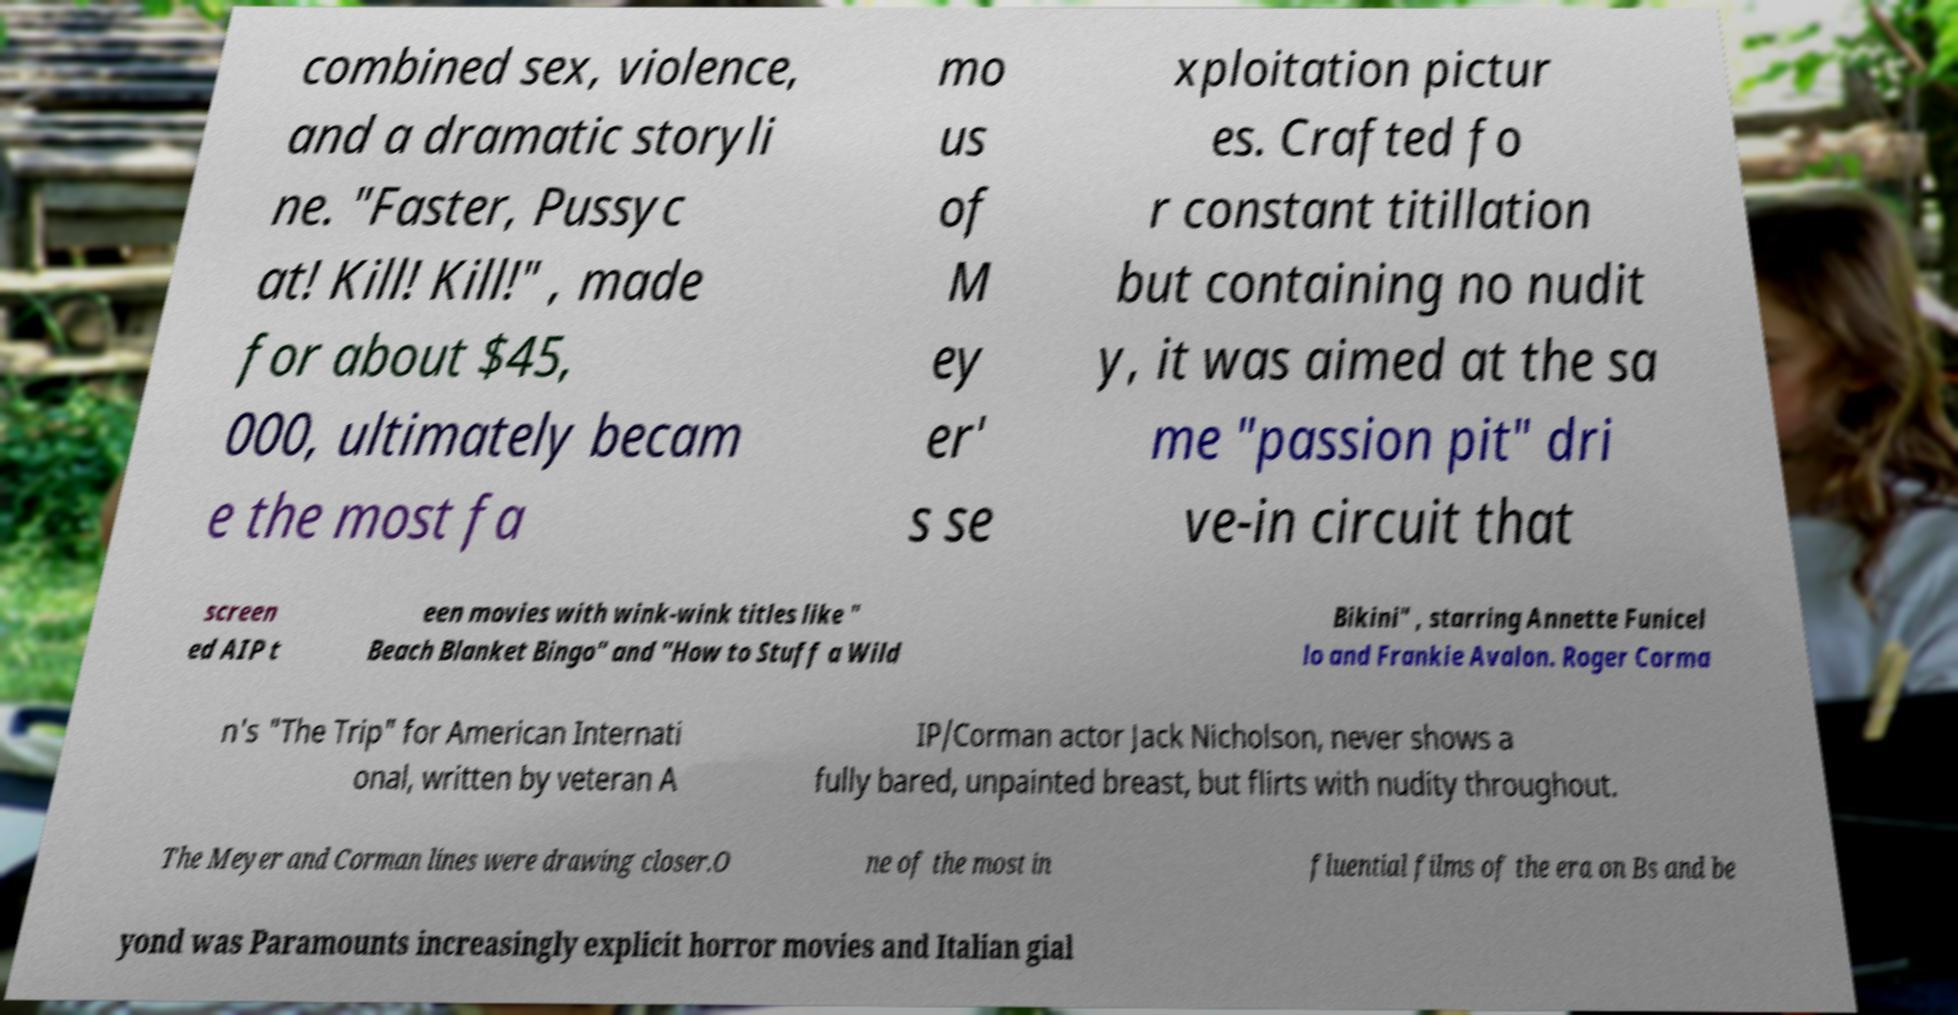Can you read and provide the text displayed in the image?This photo seems to have some interesting text. Can you extract and type it out for me? combined sex, violence, and a dramatic storyli ne. "Faster, Pussyc at! Kill! Kill!" , made for about $45, 000, ultimately becam e the most fa mo us of M ey er' s se xploitation pictur es. Crafted fo r constant titillation but containing no nudit y, it was aimed at the sa me "passion pit" dri ve-in circuit that screen ed AIP t een movies with wink-wink titles like " Beach Blanket Bingo" and "How to Stuff a Wild Bikini" , starring Annette Funicel lo and Frankie Avalon. Roger Corma n's "The Trip" for American Internati onal, written by veteran A IP/Corman actor Jack Nicholson, never shows a fully bared, unpainted breast, but flirts with nudity throughout. The Meyer and Corman lines were drawing closer.O ne of the most in fluential films of the era on Bs and be yond was Paramounts increasingly explicit horror movies and Italian gial 